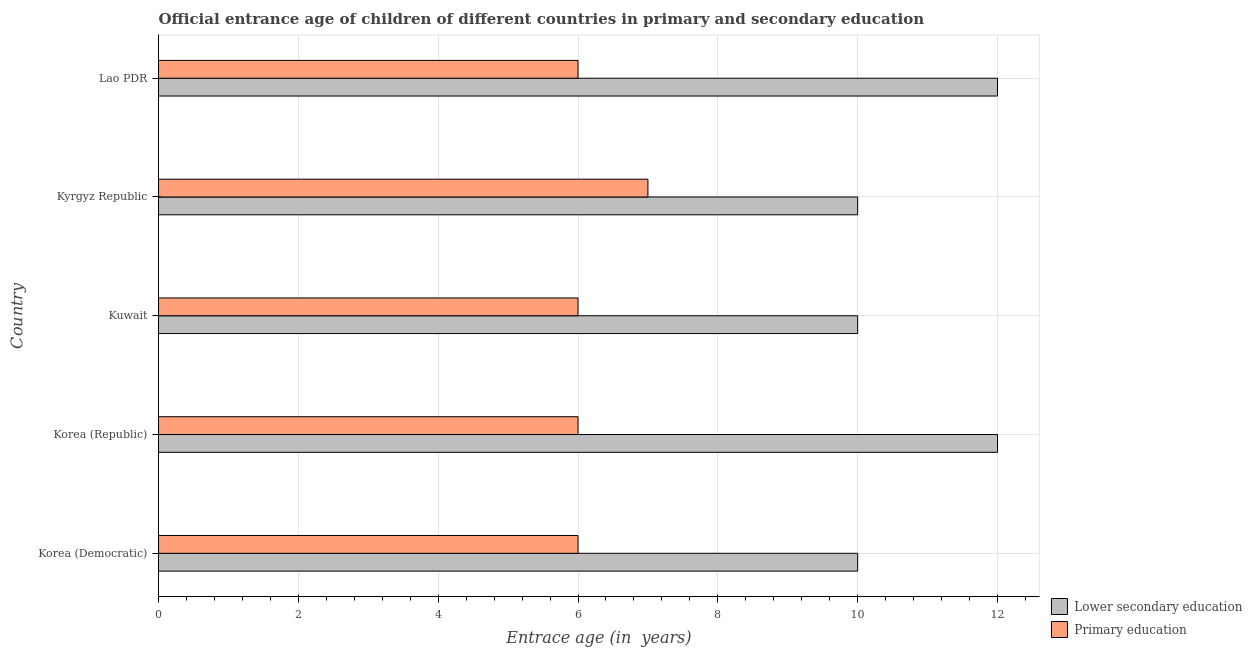Are the number of bars per tick equal to the number of legend labels?
Provide a short and direct response. Yes. How many bars are there on the 3rd tick from the top?
Make the answer very short. 2. How many bars are there on the 1st tick from the bottom?
Offer a very short reply. 2. What is the label of the 2nd group of bars from the top?
Provide a short and direct response. Kyrgyz Republic. What is the entrance age of children in lower secondary education in Kuwait?
Your answer should be compact. 10. Across all countries, what is the maximum entrance age of chiildren in primary education?
Provide a short and direct response. 7. Across all countries, what is the minimum entrance age of children in lower secondary education?
Your answer should be compact. 10. In which country was the entrance age of chiildren in primary education minimum?
Your response must be concise. Korea (Democratic). What is the total entrance age of chiildren in primary education in the graph?
Provide a short and direct response. 31. What is the difference between the entrance age of children in lower secondary education in Korea (Democratic) and that in Lao PDR?
Ensure brevity in your answer.  -2. What is the difference between the entrance age of chiildren in primary education in Kyrgyz Republic and the entrance age of children in lower secondary education in Korea (Republic)?
Your answer should be compact. -5. In how many countries, is the entrance age of children in lower secondary education greater than 11.2 years?
Offer a very short reply. 2. What is the difference between the highest and the lowest entrance age of children in lower secondary education?
Your answer should be very brief. 2. In how many countries, is the entrance age of children in lower secondary education greater than the average entrance age of children in lower secondary education taken over all countries?
Your answer should be very brief. 2. What does the 2nd bar from the top in Lao PDR represents?
Keep it short and to the point. Lower secondary education. What does the 2nd bar from the bottom in Kyrgyz Republic represents?
Provide a succinct answer. Primary education. Are all the bars in the graph horizontal?
Provide a succinct answer. Yes. How many countries are there in the graph?
Your answer should be very brief. 5. What is the difference between two consecutive major ticks on the X-axis?
Your answer should be compact. 2. Does the graph contain any zero values?
Your answer should be compact. No. Where does the legend appear in the graph?
Provide a succinct answer. Bottom right. How many legend labels are there?
Ensure brevity in your answer.  2. What is the title of the graph?
Provide a succinct answer. Official entrance age of children of different countries in primary and secondary education. Does "Old" appear as one of the legend labels in the graph?
Make the answer very short. No. What is the label or title of the X-axis?
Ensure brevity in your answer.  Entrace age (in  years). What is the label or title of the Y-axis?
Provide a short and direct response. Country. What is the Entrace age (in  years) in Lower secondary education in Korea (Democratic)?
Your answer should be very brief. 10. What is the Entrace age (in  years) of Primary education in Korea (Democratic)?
Give a very brief answer. 6. What is the Entrace age (in  years) in Primary education in Korea (Republic)?
Give a very brief answer. 6. What is the Entrace age (in  years) of Primary education in Kyrgyz Republic?
Your answer should be very brief. 7. Across all countries, what is the maximum Entrace age (in  years) of Primary education?
Make the answer very short. 7. Across all countries, what is the minimum Entrace age (in  years) of Primary education?
Your answer should be very brief. 6. What is the difference between the Entrace age (in  years) in Primary education in Korea (Democratic) and that in Korea (Republic)?
Offer a terse response. 0. What is the difference between the Entrace age (in  years) of Lower secondary education in Korea (Democratic) and that in Kuwait?
Ensure brevity in your answer.  0. What is the difference between the Entrace age (in  years) in Lower secondary education in Korea (Democratic) and that in Kyrgyz Republic?
Offer a very short reply. 0. What is the difference between the Entrace age (in  years) of Primary education in Korea (Democratic) and that in Kyrgyz Republic?
Ensure brevity in your answer.  -1. What is the difference between the Entrace age (in  years) in Primary education in Korea (Republic) and that in Kuwait?
Offer a terse response. 0. What is the difference between the Entrace age (in  years) of Lower secondary education in Korea (Republic) and that in Kyrgyz Republic?
Offer a very short reply. 2. What is the difference between the Entrace age (in  years) of Primary education in Korea (Republic) and that in Kyrgyz Republic?
Provide a short and direct response. -1. What is the difference between the Entrace age (in  years) of Lower secondary education in Korea (Republic) and that in Lao PDR?
Provide a short and direct response. 0. What is the difference between the Entrace age (in  years) in Lower secondary education in Kuwait and that in Kyrgyz Republic?
Provide a short and direct response. 0. What is the difference between the Entrace age (in  years) of Primary education in Kyrgyz Republic and that in Lao PDR?
Keep it short and to the point. 1. What is the difference between the Entrace age (in  years) in Lower secondary education in Korea (Republic) and the Entrace age (in  years) in Primary education in Kyrgyz Republic?
Ensure brevity in your answer.  5. What is the difference between the Entrace age (in  years) of Lower secondary education in Korea (Republic) and the Entrace age (in  years) of Primary education in Lao PDR?
Keep it short and to the point. 6. What is the difference between the Entrace age (in  years) in Lower secondary education in Kuwait and the Entrace age (in  years) in Primary education in Kyrgyz Republic?
Make the answer very short. 3. What is the difference between the Entrace age (in  years) in Lower secondary education in Kuwait and the Entrace age (in  years) in Primary education in Lao PDR?
Give a very brief answer. 4. What is the difference between the Entrace age (in  years) of Lower secondary education in Kyrgyz Republic and the Entrace age (in  years) of Primary education in Lao PDR?
Make the answer very short. 4. What is the average Entrace age (in  years) in Lower secondary education per country?
Offer a terse response. 10.8. What is the average Entrace age (in  years) of Primary education per country?
Ensure brevity in your answer.  6.2. What is the ratio of the Entrace age (in  years) in Lower secondary education in Korea (Democratic) to that in Kyrgyz Republic?
Your response must be concise. 1. What is the ratio of the Entrace age (in  years) of Primary education in Korea (Democratic) to that in Kyrgyz Republic?
Provide a succinct answer. 0.86. What is the ratio of the Entrace age (in  years) of Lower secondary education in Korea (Republic) to that in Lao PDR?
Your answer should be very brief. 1. What is the ratio of the Entrace age (in  years) of Primary education in Korea (Republic) to that in Lao PDR?
Ensure brevity in your answer.  1. What is the ratio of the Entrace age (in  years) of Lower secondary education in Kuwait to that in Kyrgyz Republic?
Offer a very short reply. 1. What is the ratio of the Entrace age (in  years) in Primary education in Kuwait to that in Kyrgyz Republic?
Your response must be concise. 0.86. What is the ratio of the Entrace age (in  years) of Lower secondary education in Kyrgyz Republic to that in Lao PDR?
Your answer should be very brief. 0.83. What is the ratio of the Entrace age (in  years) in Primary education in Kyrgyz Republic to that in Lao PDR?
Your answer should be compact. 1.17. What is the difference between the highest and the lowest Entrace age (in  years) of Lower secondary education?
Keep it short and to the point. 2. 